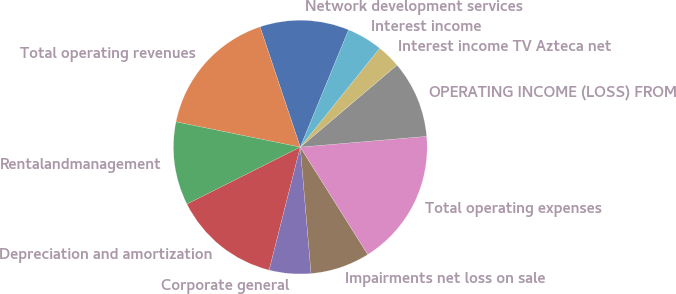Convert chart to OTSL. <chart><loc_0><loc_0><loc_500><loc_500><pie_chart><fcel>Network development services<fcel>Total operating revenues<fcel>Rentalandmanagement<fcel>Depreciation and amortization<fcel>Corporate general<fcel>Impairments net loss on sale<fcel>Total operating expenses<fcel>OPERATING INCOME (LOSS) FROM<fcel>Interest income TV Azteca net<fcel>Interest income<nl><fcel>11.36%<fcel>16.67%<fcel>10.61%<fcel>13.64%<fcel>5.3%<fcel>7.58%<fcel>17.42%<fcel>9.85%<fcel>3.03%<fcel>4.55%<nl></chart> 